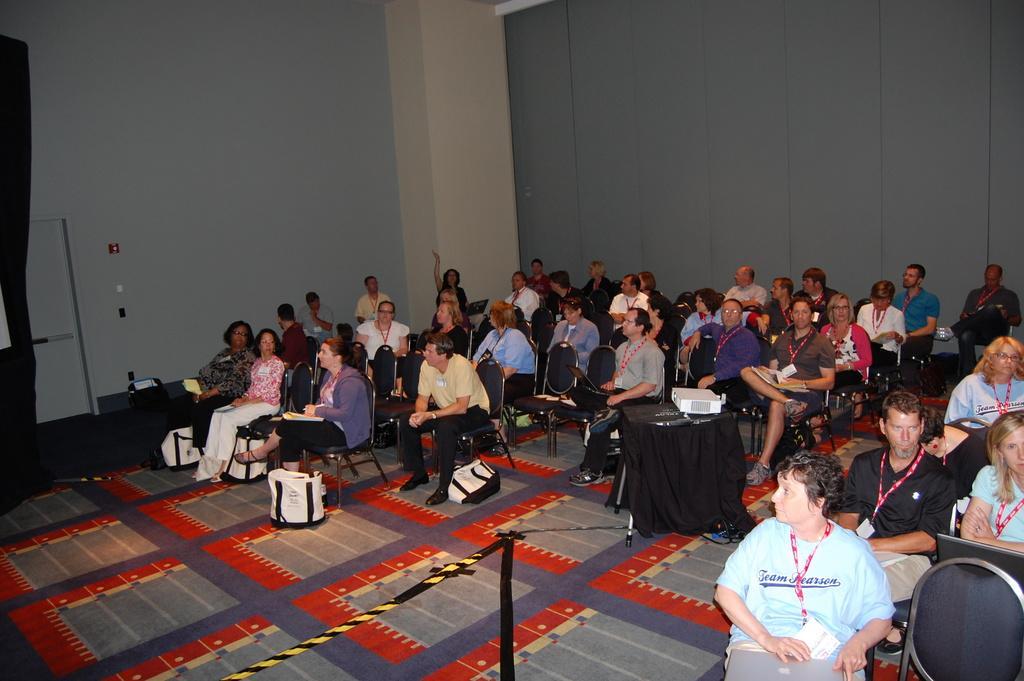Could you give a brief overview of what you see in this image? This image is clicked inside the hall. In the hall there are so many people who are sitting in the chairs by wearing the id cards. In the middle there is a projector on the table. On the floor there are white colour bags. In the background there is a wall. In the middle there is a pillar. On the left side there is a door. In the middle there is a rope which is tied to the table. 